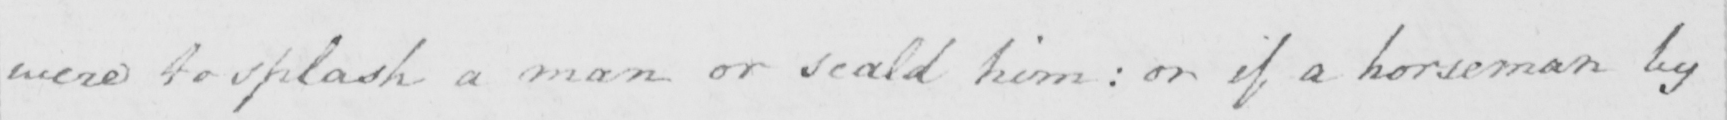Can you read and transcribe this handwriting? were to splash a man or scald him :  or if a horseman by 